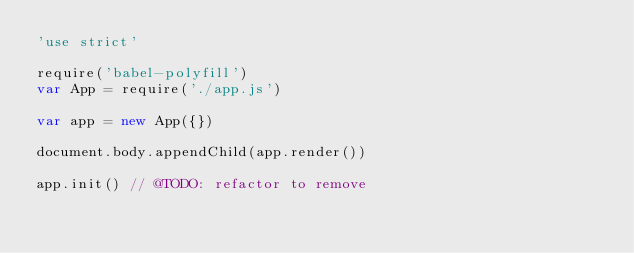<code> <loc_0><loc_0><loc_500><loc_500><_JavaScript_>'use strict'

require('babel-polyfill')
var App = require('./app.js')

var app = new App({})

document.body.appendChild(app.render())

app.init() // @TODO: refactor to remove
</code> 